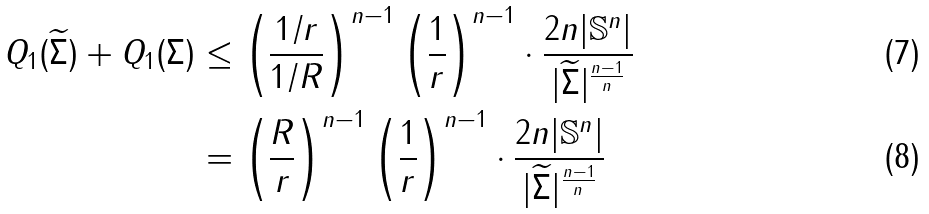Convert formula to latex. <formula><loc_0><loc_0><loc_500><loc_500>Q _ { 1 } ( \widetilde { \Sigma } ) + Q _ { 1 } ( \Sigma ) & \leq \left ( \frac { 1 / r } { 1 / R } \right ) ^ { n - 1 } \left ( \frac { 1 } { r } \right ) ^ { n - 1 } \cdot \frac { 2 n | \mathbb { S } ^ { n } | } { | \widetilde { \Sigma } | ^ { \frac { n - 1 } { n } } } \\ & = \left ( \frac { R } { r } \right ) ^ { n - 1 } \left ( \frac { 1 } { r } \right ) ^ { n - 1 } \cdot \frac { 2 n | \mathbb { S } ^ { n } | } { | \widetilde { \Sigma } | ^ { \frac { n - 1 } { n } } }</formula> 